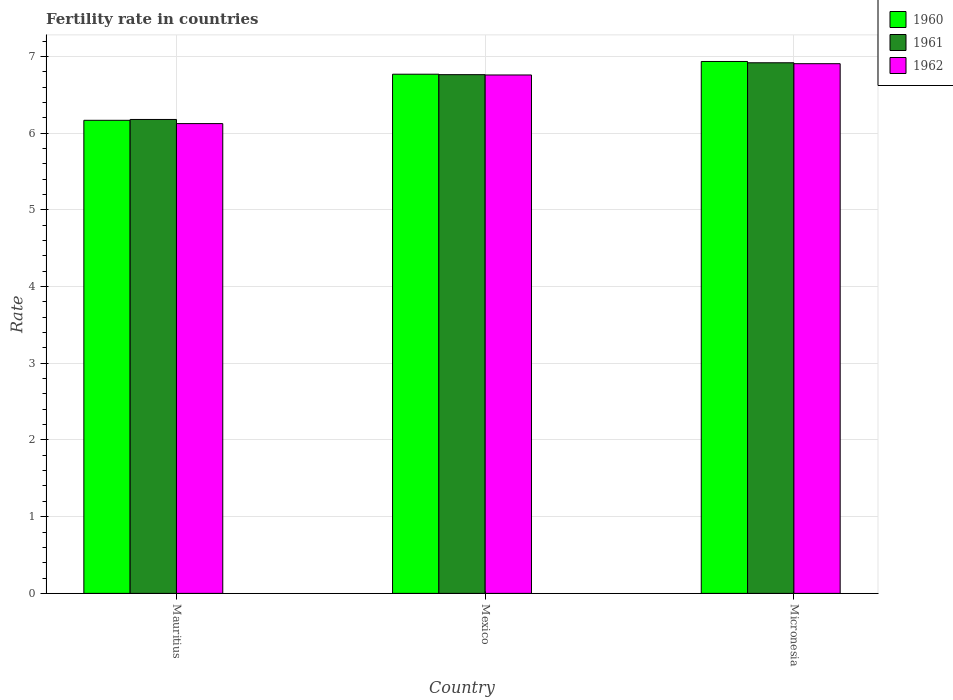How many different coloured bars are there?
Your answer should be compact. 3. Are the number of bars per tick equal to the number of legend labels?
Make the answer very short. Yes. Are the number of bars on each tick of the X-axis equal?
Provide a succinct answer. Yes. How many bars are there on the 3rd tick from the right?
Keep it short and to the point. 3. What is the label of the 1st group of bars from the left?
Offer a very short reply. Mauritius. In how many cases, is the number of bars for a given country not equal to the number of legend labels?
Provide a succinct answer. 0. What is the fertility rate in 1960 in Mauritius?
Provide a succinct answer. 6.17. Across all countries, what is the maximum fertility rate in 1962?
Offer a very short reply. 6.91. Across all countries, what is the minimum fertility rate in 1960?
Your answer should be very brief. 6.17. In which country was the fertility rate in 1962 maximum?
Offer a very short reply. Micronesia. In which country was the fertility rate in 1961 minimum?
Your answer should be very brief. Mauritius. What is the total fertility rate in 1962 in the graph?
Provide a succinct answer. 19.79. What is the difference between the fertility rate in 1962 in Mauritius and that in Mexico?
Your response must be concise. -0.63. What is the difference between the fertility rate in 1961 in Mexico and the fertility rate in 1962 in Micronesia?
Your response must be concise. -0.14. What is the average fertility rate in 1961 per country?
Offer a terse response. 6.62. What is the difference between the fertility rate of/in 1961 and fertility rate of/in 1960 in Mexico?
Provide a short and direct response. -0.01. What is the ratio of the fertility rate in 1960 in Mexico to that in Micronesia?
Your response must be concise. 0.98. Is the fertility rate in 1960 in Mauritius less than that in Micronesia?
Your response must be concise. Yes. Is the difference between the fertility rate in 1961 in Mauritius and Mexico greater than the difference between the fertility rate in 1960 in Mauritius and Mexico?
Provide a succinct answer. Yes. What is the difference between the highest and the second highest fertility rate in 1960?
Offer a terse response. -0.77. What is the difference between the highest and the lowest fertility rate in 1962?
Provide a short and direct response. 0.78. What does the 3rd bar from the right in Mauritius represents?
Offer a very short reply. 1960. Is it the case that in every country, the sum of the fertility rate in 1961 and fertility rate in 1962 is greater than the fertility rate in 1960?
Provide a short and direct response. Yes. How many bars are there?
Offer a terse response. 9. How many countries are there in the graph?
Provide a succinct answer. 3. What is the difference between two consecutive major ticks on the Y-axis?
Offer a terse response. 1. What is the title of the graph?
Provide a short and direct response. Fertility rate in countries. Does "1982" appear as one of the legend labels in the graph?
Offer a terse response. No. What is the label or title of the X-axis?
Give a very brief answer. Country. What is the label or title of the Y-axis?
Offer a very short reply. Rate. What is the Rate of 1960 in Mauritius?
Ensure brevity in your answer.  6.17. What is the Rate of 1961 in Mauritius?
Ensure brevity in your answer.  6.18. What is the Rate in 1962 in Mauritius?
Give a very brief answer. 6.12. What is the Rate in 1960 in Mexico?
Provide a short and direct response. 6.77. What is the Rate in 1961 in Mexico?
Make the answer very short. 6.76. What is the Rate of 1962 in Mexico?
Your answer should be very brief. 6.76. What is the Rate of 1960 in Micronesia?
Make the answer very short. 6.93. What is the Rate in 1961 in Micronesia?
Keep it short and to the point. 6.92. What is the Rate in 1962 in Micronesia?
Provide a short and direct response. 6.91. Across all countries, what is the maximum Rate of 1960?
Your response must be concise. 6.93. Across all countries, what is the maximum Rate of 1961?
Provide a succinct answer. 6.92. Across all countries, what is the maximum Rate in 1962?
Give a very brief answer. 6.91. Across all countries, what is the minimum Rate in 1960?
Keep it short and to the point. 6.17. Across all countries, what is the minimum Rate of 1961?
Offer a very short reply. 6.18. Across all countries, what is the minimum Rate in 1962?
Offer a very short reply. 6.12. What is the total Rate in 1960 in the graph?
Offer a terse response. 19.87. What is the total Rate of 1961 in the graph?
Your response must be concise. 19.86. What is the total Rate of 1962 in the graph?
Your answer should be compact. 19.79. What is the difference between the Rate of 1960 in Mauritius and that in Mexico?
Your answer should be compact. -0.6. What is the difference between the Rate in 1961 in Mauritius and that in Mexico?
Ensure brevity in your answer.  -0.58. What is the difference between the Rate of 1962 in Mauritius and that in Mexico?
Ensure brevity in your answer.  -0.63. What is the difference between the Rate of 1960 in Mauritius and that in Micronesia?
Your response must be concise. -0.77. What is the difference between the Rate in 1961 in Mauritius and that in Micronesia?
Offer a very short reply. -0.74. What is the difference between the Rate in 1962 in Mauritius and that in Micronesia?
Your answer should be very brief. -0.78. What is the difference between the Rate in 1960 in Mexico and that in Micronesia?
Your answer should be compact. -0.17. What is the difference between the Rate of 1961 in Mexico and that in Micronesia?
Your response must be concise. -0.15. What is the difference between the Rate in 1962 in Mexico and that in Micronesia?
Your answer should be very brief. -0.15. What is the difference between the Rate of 1960 in Mauritius and the Rate of 1961 in Mexico?
Keep it short and to the point. -0.59. What is the difference between the Rate of 1960 in Mauritius and the Rate of 1962 in Mexico?
Make the answer very short. -0.59. What is the difference between the Rate of 1961 in Mauritius and the Rate of 1962 in Mexico?
Your response must be concise. -0.58. What is the difference between the Rate in 1960 in Mauritius and the Rate in 1961 in Micronesia?
Give a very brief answer. -0.75. What is the difference between the Rate in 1960 in Mauritius and the Rate in 1962 in Micronesia?
Your answer should be compact. -0.74. What is the difference between the Rate of 1961 in Mauritius and the Rate of 1962 in Micronesia?
Offer a very short reply. -0.73. What is the difference between the Rate in 1960 in Mexico and the Rate in 1961 in Micronesia?
Keep it short and to the point. -0.15. What is the difference between the Rate in 1960 in Mexico and the Rate in 1962 in Micronesia?
Provide a succinct answer. -0.14. What is the difference between the Rate in 1961 in Mexico and the Rate in 1962 in Micronesia?
Make the answer very short. -0.14. What is the average Rate of 1960 per country?
Give a very brief answer. 6.62. What is the average Rate in 1961 per country?
Ensure brevity in your answer.  6.62. What is the average Rate in 1962 per country?
Your answer should be very brief. 6.6. What is the difference between the Rate of 1960 and Rate of 1961 in Mauritius?
Offer a terse response. -0.01. What is the difference between the Rate of 1960 and Rate of 1962 in Mauritius?
Your answer should be very brief. 0.04. What is the difference between the Rate in 1961 and Rate in 1962 in Mauritius?
Give a very brief answer. 0.05. What is the difference between the Rate of 1960 and Rate of 1961 in Mexico?
Keep it short and to the point. 0.01. What is the difference between the Rate in 1960 and Rate in 1962 in Mexico?
Offer a terse response. 0.01. What is the difference between the Rate of 1961 and Rate of 1962 in Mexico?
Your answer should be very brief. 0. What is the difference between the Rate in 1960 and Rate in 1961 in Micronesia?
Ensure brevity in your answer.  0.02. What is the difference between the Rate in 1960 and Rate in 1962 in Micronesia?
Your answer should be very brief. 0.03. What is the difference between the Rate in 1961 and Rate in 1962 in Micronesia?
Provide a succinct answer. 0.01. What is the ratio of the Rate of 1960 in Mauritius to that in Mexico?
Your response must be concise. 0.91. What is the ratio of the Rate of 1961 in Mauritius to that in Mexico?
Offer a very short reply. 0.91. What is the ratio of the Rate in 1962 in Mauritius to that in Mexico?
Give a very brief answer. 0.91. What is the ratio of the Rate in 1960 in Mauritius to that in Micronesia?
Make the answer very short. 0.89. What is the ratio of the Rate in 1961 in Mauritius to that in Micronesia?
Give a very brief answer. 0.89. What is the ratio of the Rate of 1962 in Mauritius to that in Micronesia?
Your answer should be very brief. 0.89. What is the ratio of the Rate in 1960 in Mexico to that in Micronesia?
Keep it short and to the point. 0.98. What is the ratio of the Rate of 1961 in Mexico to that in Micronesia?
Provide a succinct answer. 0.98. What is the ratio of the Rate in 1962 in Mexico to that in Micronesia?
Your response must be concise. 0.98. What is the difference between the highest and the second highest Rate of 1960?
Keep it short and to the point. 0.17. What is the difference between the highest and the second highest Rate in 1961?
Make the answer very short. 0.15. What is the difference between the highest and the second highest Rate in 1962?
Your response must be concise. 0.15. What is the difference between the highest and the lowest Rate of 1960?
Make the answer very short. 0.77. What is the difference between the highest and the lowest Rate of 1961?
Your answer should be compact. 0.74. What is the difference between the highest and the lowest Rate in 1962?
Ensure brevity in your answer.  0.78. 